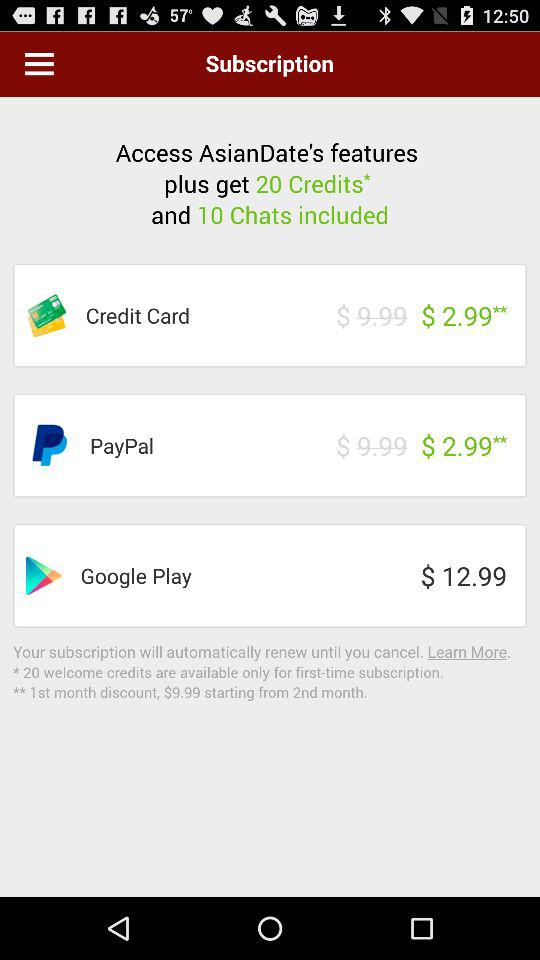What is the number of credits we can get on features plus? The number of credits you can get is 20. 